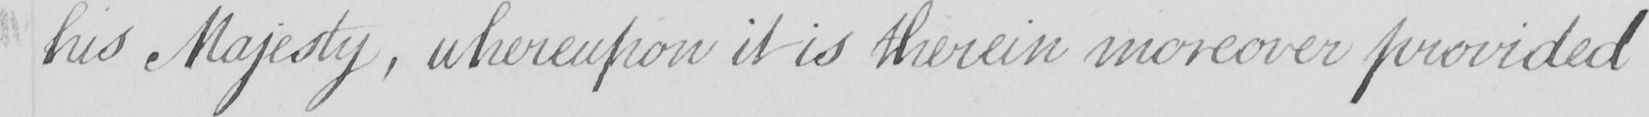Please provide the text content of this handwritten line. his Majesty , wherefore it is therein moreover provided 